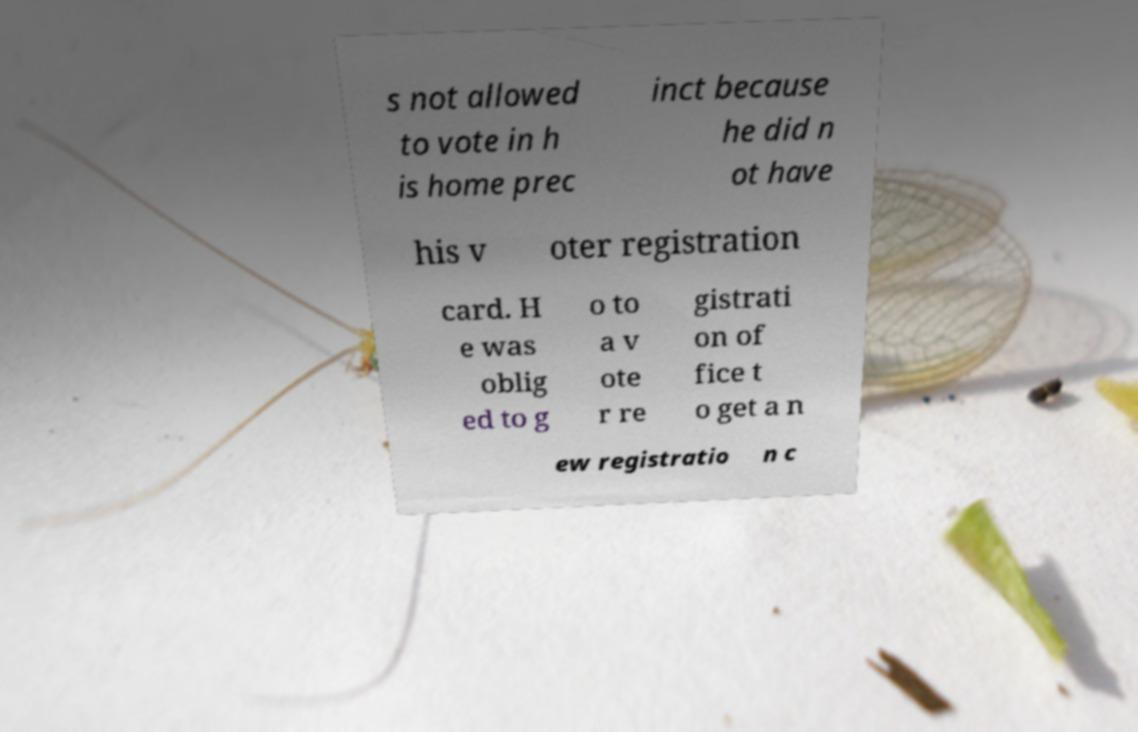Please read and relay the text visible in this image. What does it say? s not allowed to vote in h is home prec inct because he did n ot have his v oter registration card. H e was oblig ed to g o to a v ote r re gistrati on of fice t o get a n ew registratio n c 